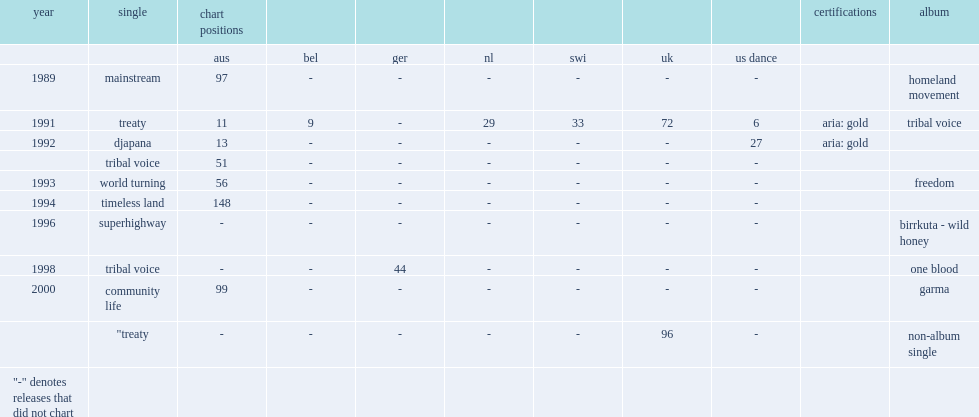Which album did yothu yindi do "djapana (sunset dreaming)" in 1992? Tribal voice. 